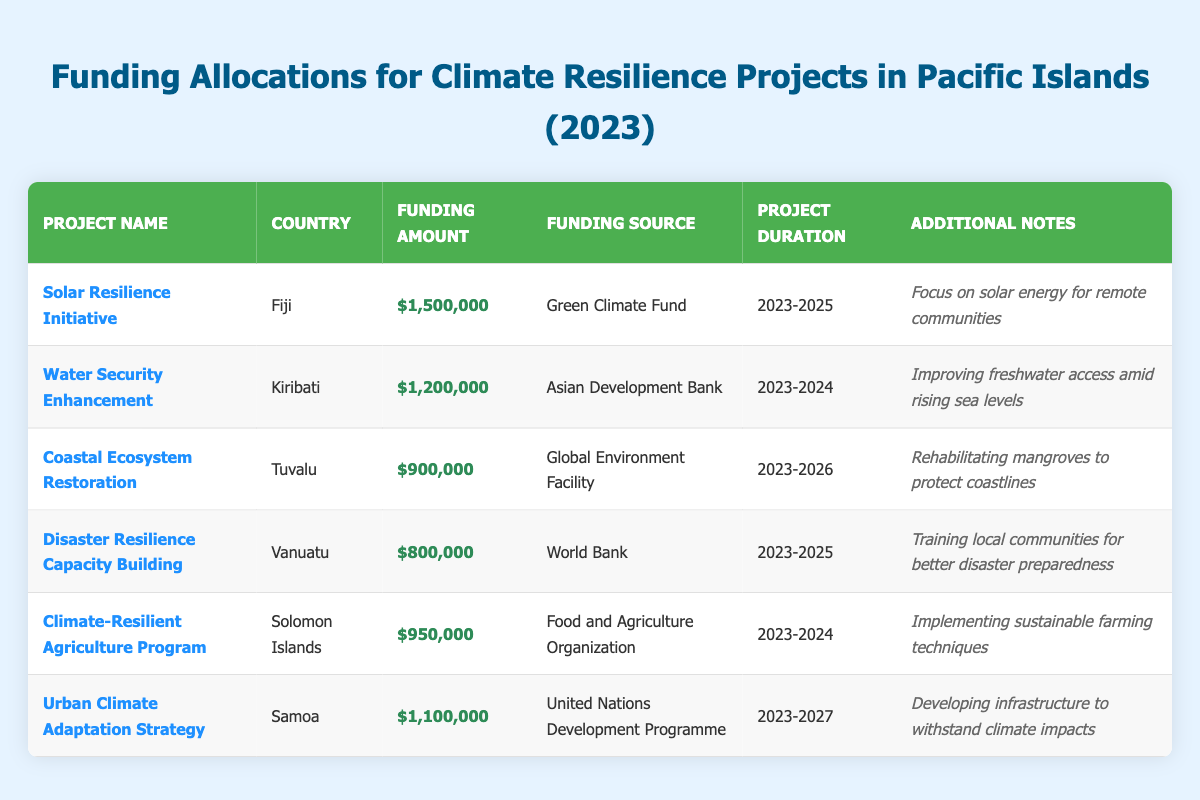What is the funding amount for the Water Security Enhancement project? The funding amount is listed under the corresponding project name in the table. For the Water Security Enhancement project, it shows $1,200,000.
Answer: $1,200,000 Which country is implementing the Urban Climate Adaptation Strategy? The country associated with the Urban Climate Adaptation Strategy can be found in the same row as the project name. It shows Samoa as the implementing country.
Answer: Samoa What is the total funding amount allocated for projects in Kiribati? The table contains only one project in Kiribati, which is the Water Security Enhancement project with a funding amount of $1,200,000. Therefore, the total funding amount for projects in Kiribati is simply this value.
Answer: $1,200,000 Which project has the longest duration? By comparing the project durations listed in the table, the Urban Climate Adaptation Strategy lasts from 2023 to 2027, making it the longest duration of 5 years compared to the others.
Answer: Urban Climate Adaptation Strategy Is there a project focused on improving freshwater access? The Water Security Enhancement project in Kiribati specifically mentions improving freshwater access in its additional notes, confirming that there is indeed a project with this focus.
Answer: Yes What is the average funding amount of the projects listed in the table? First, we total all the funding amounts: $1,500,000 (Fiji) + $1,200,000 (Kiribati) + $900,000 (Tuvalu) + $800,000 (Vanuatu) + $950,000 (Solomon Islands) + $1,100,000 (Samoa) = $6,450,000. There are 6 projects; thus, we find the average by dividing: $6,450,000 / 6 = $1,075,000.
Answer: $1,075,000 Which funding source provided the least amount of funding? We can look at the funding amounts associated with each project. The Disaster Resilience Capacity Building project in Vanuatu has the lowest funding amount of $800,000, making its sourcing from the World Bank the least amount.
Answer: World Bank How many projects are funded by the Asian Development Bank? By examining the table, there is one project, which is the Water Security Enhancement in Kiribati, funded by the Asian Development Bank.
Answer: 1 What is the combined funding amount for projects in Tuvalu and Vanuatu? We'll sum the funding amounts for the Coastal Ecosystem Restoration in Tuvalu ($900,000) and the Disaster Resilience Capacity Building in Vanuatu ($800,000). The total is $900,000 + $800,000 = $1,700,000.
Answer: $1,700,000 Does the Solar Resilience Initiative focus on solar energy for urban areas? The additional notes state that the focus is on solar energy for remote communities, not urban areas. Therefore, the answer is no.
Answer: No Which two projects have funding amounts greater than $1 million? By scanning the funding amounts, the Solar Resilience Initiative ($1,500,000) and the Water Security Enhancement ($1,200,000) are identified as being greater than $1 million.
Answer: Solar Resilience Initiative, Water Security Enhancement 